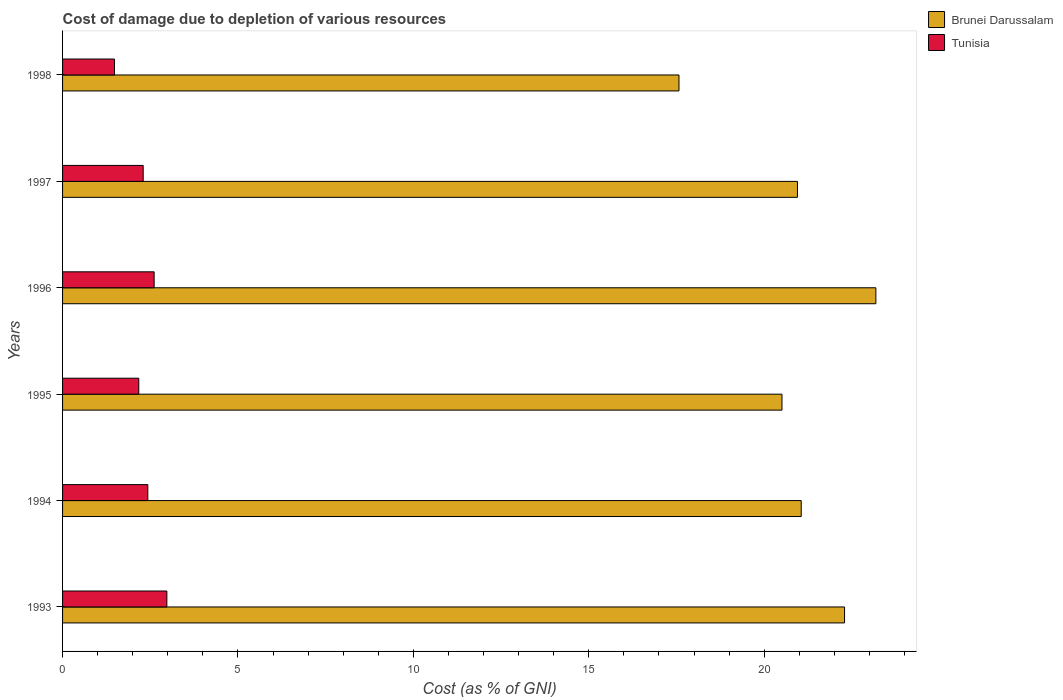Are the number of bars on each tick of the Y-axis equal?
Offer a very short reply. Yes. How many bars are there on the 6th tick from the top?
Provide a short and direct response. 2. How many bars are there on the 5th tick from the bottom?
Your answer should be very brief. 2. What is the label of the 5th group of bars from the top?
Your response must be concise. 1994. What is the cost of damage caused due to the depletion of various resources in Tunisia in 1996?
Make the answer very short. 2.61. Across all years, what is the maximum cost of damage caused due to the depletion of various resources in Tunisia?
Your answer should be compact. 2.97. Across all years, what is the minimum cost of damage caused due to the depletion of various resources in Brunei Darussalam?
Give a very brief answer. 17.57. In which year was the cost of damage caused due to the depletion of various resources in Tunisia maximum?
Your response must be concise. 1993. What is the total cost of damage caused due to the depletion of various resources in Tunisia in the graph?
Give a very brief answer. 13.97. What is the difference between the cost of damage caused due to the depletion of various resources in Tunisia in 1995 and that in 1996?
Provide a succinct answer. -0.44. What is the difference between the cost of damage caused due to the depletion of various resources in Brunei Darussalam in 1997 and the cost of damage caused due to the depletion of various resources in Tunisia in 1998?
Offer a terse response. 19.47. What is the average cost of damage caused due to the depletion of various resources in Brunei Darussalam per year?
Your answer should be very brief. 20.93. In the year 1998, what is the difference between the cost of damage caused due to the depletion of various resources in Brunei Darussalam and cost of damage caused due to the depletion of various resources in Tunisia?
Ensure brevity in your answer.  16.09. In how many years, is the cost of damage caused due to the depletion of various resources in Tunisia greater than 16 %?
Ensure brevity in your answer.  0. What is the ratio of the cost of damage caused due to the depletion of various resources in Brunei Darussalam in 1993 to that in 1995?
Offer a terse response. 1.09. Is the difference between the cost of damage caused due to the depletion of various resources in Brunei Darussalam in 1993 and 1994 greater than the difference between the cost of damage caused due to the depletion of various resources in Tunisia in 1993 and 1994?
Provide a short and direct response. Yes. What is the difference between the highest and the second highest cost of damage caused due to the depletion of various resources in Tunisia?
Give a very brief answer. 0.36. What is the difference between the highest and the lowest cost of damage caused due to the depletion of various resources in Brunei Darussalam?
Offer a very short reply. 5.61. In how many years, is the cost of damage caused due to the depletion of various resources in Tunisia greater than the average cost of damage caused due to the depletion of various resources in Tunisia taken over all years?
Provide a succinct answer. 3. What does the 2nd bar from the top in 1997 represents?
Make the answer very short. Brunei Darussalam. What does the 2nd bar from the bottom in 1995 represents?
Your response must be concise. Tunisia. How many bars are there?
Your answer should be compact. 12. Are all the bars in the graph horizontal?
Keep it short and to the point. Yes. What is the difference between two consecutive major ticks on the X-axis?
Give a very brief answer. 5. Are the values on the major ticks of X-axis written in scientific E-notation?
Make the answer very short. No. Does the graph contain any zero values?
Offer a very short reply. No. Does the graph contain grids?
Offer a very short reply. No. Where does the legend appear in the graph?
Your answer should be very brief. Top right. How many legend labels are there?
Give a very brief answer. 2. How are the legend labels stacked?
Provide a succinct answer. Vertical. What is the title of the graph?
Keep it short and to the point. Cost of damage due to depletion of various resources. What is the label or title of the X-axis?
Ensure brevity in your answer.  Cost (as % of GNI). What is the label or title of the Y-axis?
Your answer should be very brief. Years. What is the Cost (as % of GNI) of Brunei Darussalam in 1993?
Provide a short and direct response. 22.29. What is the Cost (as % of GNI) of Tunisia in 1993?
Provide a short and direct response. 2.97. What is the Cost (as % of GNI) in Brunei Darussalam in 1994?
Provide a succinct answer. 21.06. What is the Cost (as % of GNI) in Tunisia in 1994?
Your answer should be very brief. 2.43. What is the Cost (as % of GNI) of Brunei Darussalam in 1995?
Offer a very short reply. 20.51. What is the Cost (as % of GNI) in Tunisia in 1995?
Ensure brevity in your answer.  2.17. What is the Cost (as % of GNI) in Brunei Darussalam in 1996?
Make the answer very short. 23.18. What is the Cost (as % of GNI) of Tunisia in 1996?
Ensure brevity in your answer.  2.61. What is the Cost (as % of GNI) of Brunei Darussalam in 1997?
Make the answer very short. 20.95. What is the Cost (as % of GNI) in Tunisia in 1997?
Offer a terse response. 2.3. What is the Cost (as % of GNI) in Brunei Darussalam in 1998?
Ensure brevity in your answer.  17.57. What is the Cost (as % of GNI) in Tunisia in 1998?
Provide a short and direct response. 1.48. Across all years, what is the maximum Cost (as % of GNI) of Brunei Darussalam?
Your answer should be compact. 23.18. Across all years, what is the maximum Cost (as % of GNI) in Tunisia?
Give a very brief answer. 2.97. Across all years, what is the minimum Cost (as % of GNI) in Brunei Darussalam?
Your response must be concise. 17.57. Across all years, what is the minimum Cost (as % of GNI) in Tunisia?
Offer a terse response. 1.48. What is the total Cost (as % of GNI) of Brunei Darussalam in the graph?
Provide a short and direct response. 125.56. What is the total Cost (as % of GNI) in Tunisia in the graph?
Ensure brevity in your answer.  13.97. What is the difference between the Cost (as % of GNI) of Brunei Darussalam in 1993 and that in 1994?
Your answer should be very brief. 1.24. What is the difference between the Cost (as % of GNI) of Tunisia in 1993 and that in 1994?
Your answer should be very brief. 0.54. What is the difference between the Cost (as % of GNI) in Brunei Darussalam in 1993 and that in 1995?
Ensure brevity in your answer.  1.78. What is the difference between the Cost (as % of GNI) in Tunisia in 1993 and that in 1995?
Ensure brevity in your answer.  0.8. What is the difference between the Cost (as % of GNI) of Brunei Darussalam in 1993 and that in 1996?
Give a very brief answer. -0.89. What is the difference between the Cost (as % of GNI) of Tunisia in 1993 and that in 1996?
Your response must be concise. 0.36. What is the difference between the Cost (as % of GNI) of Brunei Darussalam in 1993 and that in 1997?
Provide a succinct answer. 1.34. What is the difference between the Cost (as % of GNI) of Tunisia in 1993 and that in 1997?
Your response must be concise. 0.67. What is the difference between the Cost (as % of GNI) in Brunei Darussalam in 1993 and that in 1998?
Make the answer very short. 4.72. What is the difference between the Cost (as % of GNI) of Tunisia in 1993 and that in 1998?
Keep it short and to the point. 1.49. What is the difference between the Cost (as % of GNI) in Brunei Darussalam in 1994 and that in 1995?
Ensure brevity in your answer.  0.55. What is the difference between the Cost (as % of GNI) in Tunisia in 1994 and that in 1995?
Ensure brevity in your answer.  0.26. What is the difference between the Cost (as % of GNI) of Brunei Darussalam in 1994 and that in 1996?
Your response must be concise. -2.13. What is the difference between the Cost (as % of GNI) of Tunisia in 1994 and that in 1996?
Make the answer very short. -0.18. What is the difference between the Cost (as % of GNI) in Brunei Darussalam in 1994 and that in 1997?
Offer a terse response. 0.11. What is the difference between the Cost (as % of GNI) in Tunisia in 1994 and that in 1997?
Offer a very short reply. 0.13. What is the difference between the Cost (as % of GNI) of Brunei Darussalam in 1994 and that in 1998?
Make the answer very short. 3.48. What is the difference between the Cost (as % of GNI) of Tunisia in 1994 and that in 1998?
Ensure brevity in your answer.  0.95. What is the difference between the Cost (as % of GNI) of Brunei Darussalam in 1995 and that in 1996?
Your response must be concise. -2.68. What is the difference between the Cost (as % of GNI) of Tunisia in 1995 and that in 1996?
Provide a succinct answer. -0.44. What is the difference between the Cost (as % of GNI) in Brunei Darussalam in 1995 and that in 1997?
Make the answer very short. -0.44. What is the difference between the Cost (as % of GNI) in Tunisia in 1995 and that in 1997?
Your response must be concise. -0.13. What is the difference between the Cost (as % of GNI) in Brunei Darussalam in 1995 and that in 1998?
Give a very brief answer. 2.94. What is the difference between the Cost (as % of GNI) in Tunisia in 1995 and that in 1998?
Make the answer very short. 0.69. What is the difference between the Cost (as % of GNI) of Brunei Darussalam in 1996 and that in 1997?
Offer a terse response. 2.24. What is the difference between the Cost (as % of GNI) of Tunisia in 1996 and that in 1997?
Offer a very short reply. 0.31. What is the difference between the Cost (as % of GNI) in Brunei Darussalam in 1996 and that in 1998?
Your answer should be compact. 5.61. What is the difference between the Cost (as % of GNI) in Tunisia in 1996 and that in 1998?
Give a very brief answer. 1.13. What is the difference between the Cost (as % of GNI) in Brunei Darussalam in 1997 and that in 1998?
Make the answer very short. 3.38. What is the difference between the Cost (as % of GNI) in Tunisia in 1997 and that in 1998?
Your response must be concise. 0.82. What is the difference between the Cost (as % of GNI) of Brunei Darussalam in 1993 and the Cost (as % of GNI) of Tunisia in 1994?
Ensure brevity in your answer.  19.86. What is the difference between the Cost (as % of GNI) in Brunei Darussalam in 1993 and the Cost (as % of GNI) in Tunisia in 1995?
Your answer should be compact. 20.12. What is the difference between the Cost (as % of GNI) in Brunei Darussalam in 1993 and the Cost (as % of GNI) in Tunisia in 1996?
Ensure brevity in your answer.  19.68. What is the difference between the Cost (as % of GNI) in Brunei Darussalam in 1993 and the Cost (as % of GNI) in Tunisia in 1997?
Offer a terse response. 19.99. What is the difference between the Cost (as % of GNI) in Brunei Darussalam in 1993 and the Cost (as % of GNI) in Tunisia in 1998?
Your answer should be very brief. 20.81. What is the difference between the Cost (as % of GNI) in Brunei Darussalam in 1994 and the Cost (as % of GNI) in Tunisia in 1995?
Offer a terse response. 18.88. What is the difference between the Cost (as % of GNI) in Brunei Darussalam in 1994 and the Cost (as % of GNI) in Tunisia in 1996?
Ensure brevity in your answer.  18.44. What is the difference between the Cost (as % of GNI) of Brunei Darussalam in 1994 and the Cost (as % of GNI) of Tunisia in 1997?
Provide a short and direct response. 18.76. What is the difference between the Cost (as % of GNI) in Brunei Darussalam in 1994 and the Cost (as % of GNI) in Tunisia in 1998?
Give a very brief answer. 19.57. What is the difference between the Cost (as % of GNI) of Brunei Darussalam in 1995 and the Cost (as % of GNI) of Tunisia in 1996?
Provide a short and direct response. 17.9. What is the difference between the Cost (as % of GNI) in Brunei Darussalam in 1995 and the Cost (as % of GNI) in Tunisia in 1997?
Your response must be concise. 18.21. What is the difference between the Cost (as % of GNI) in Brunei Darussalam in 1995 and the Cost (as % of GNI) in Tunisia in 1998?
Keep it short and to the point. 19.03. What is the difference between the Cost (as % of GNI) of Brunei Darussalam in 1996 and the Cost (as % of GNI) of Tunisia in 1997?
Your answer should be compact. 20.89. What is the difference between the Cost (as % of GNI) of Brunei Darussalam in 1996 and the Cost (as % of GNI) of Tunisia in 1998?
Provide a short and direct response. 21.7. What is the difference between the Cost (as % of GNI) of Brunei Darussalam in 1997 and the Cost (as % of GNI) of Tunisia in 1998?
Your answer should be very brief. 19.47. What is the average Cost (as % of GNI) in Brunei Darussalam per year?
Keep it short and to the point. 20.93. What is the average Cost (as % of GNI) of Tunisia per year?
Offer a very short reply. 2.33. In the year 1993, what is the difference between the Cost (as % of GNI) in Brunei Darussalam and Cost (as % of GNI) in Tunisia?
Provide a short and direct response. 19.32. In the year 1994, what is the difference between the Cost (as % of GNI) in Brunei Darussalam and Cost (as % of GNI) in Tunisia?
Your answer should be very brief. 18.63. In the year 1995, what is the difference between the Cost (as % of GNI) of Brunei Darussalam and Cost (as % of GNI) of Tunisia?
Your answer should be very brief. 18.33. In the year 1996, what is the difference between the Cost (as % of GNI) in Brunei Darussalam and Cost (as % of GNI) in Tunisia?
Offer a very short reply. 20.57. In the year 1997, what is the difference between the Cost (as % of GNI) in Brunei Darussalam and Cost (as % of GNI) in Tunisia?
Keep it short and to the point. 18.65. In the year 1998, what is the difference between the Cost (as % of GNI) of Brunei Darussalam and Cost (as % of GNI) of Tunisia?
Give a very brief answer. 16.09. What is the ratio of the Cost (as % of GNI) of Brunei Darussalam in 1993 to that in 1994?
Offer a very short reply. 1.06. What is the ratio of the Cost (as % of GNI) of Tunisia in 1993 to that in 1994?
Provide a short and direct response. 1.22. What is the ratio of the Cost (as % of GNI) of Brunei Darussalam in 1993 to that in 1995?
Provide a succinct answer. 1.09. What is the ratio of the Cost (as % of GNI) in Tunisia in 1993 to that in 1995?
Your response must be concise. 1.37. What is the ratio of the Cost (as % of GNI) of Brunei Darussalam in 1993 to that in 1996?
Make the answer very short. 0.96. What is the ratio of the Cost (as % of GNI) of Tunisia in 1993 to that in 1996?
Your response must be concise. 1.14. What is the ratio of the Cost (as % of GNI) of Brunei Darussalam in 1993 to that in 1997?
Make the answer very short. 1.06. What is the ratio of the Cost (as % of GNI) of Tunisia in 1993 to that in 1997?
Make the answer very short. 1.29. What is the ratio of the Cost (as % of GNI) in Brunei Darussalam in 1993 to that in 1998?
Ensure brevity in your answer.  1.27. What is the ratio of the Cost (as % of GNI) of Tunisia in 1993 to that in 1998?
Your answer should be compact. 2.01. What is the ratio of the Cost (as % of GNI) of Brunei Darussalam in 1994 to that in 1995?
Ensure brevity in your answer.  1.03. What is the ratio of the Cost (as % of GNI) in Tunisia in 1994 to that in 1995?
Offer a very short reply. 1.12. What is the ratio of the Cost (as % of GNI) in Brunei Darussalam in 1994 to that in 1996?
Your answer should be compact. 0.91. What is the ratio of the Cost (as % of GNI) of Tunisia in 1994 to that in 1996?
Provide a short and direct response. 0.93. What is the ratio of the Cost (as % of GNI) in Tunisia in 1994 to that in 1997?
Provide a succinct answer. 1.06. What is the ratio of the Cost (as % of GNI) in Brunei Darussalam in 1994 to that in 1998?
Your answer should be very brief. 1.2. What is the ratio of the Cost (as % of GNI) in Tunisia in 1994 to that in 1998?
Ensure brevity in your answer.  1.64. What is the ratio of the Cost (as % of GNI) of Brunei Darussalam in 1995 to that in 1996?
Make the answer very short. 0.88. What is the ratio of the Cost (as % of GNI) in Tunisia in 1995 to that in 1996?
Provide a succinct answer. 0.83. What is the ratio of the Cost (as % of GNI) of Brunei Darussalam in 1995 to that in 1997?
Offer a terse response. 0.98. What is the ratio of the Cost (as % of GNI) in Tunisia in 1995 to that in 1997?
Your answer should be very brief. 0.95. What is the ratio of the Cost (as % of GNI) of Brunei Darussalam in 1995 to that in 1998?
Offer a very short reply. 1.17. What is the ratio of the Cost (as % of GNI) of Tunisia in 1995 to that in 1998?
Keep it short and to the point. 1.47. What is the ratio of the Cost (as % of GNI) of Brunei Darussalam in 1996 to that in 1997?
Your answer should be very brief. 1.11. What is the ratio of the Cost (as % of GNI) of Tunisia in 1996 to that in 1997?
Give a very brief answer. 1.14. What is the ratio of the Cost (as % of GNI) of Brunei Darussalam in 1996 to that in 1998?
Give a very brief answer. 1.32. What is the ratio of the Cost (as % of GNI) of Tunisia in 1996 to that in 1998?
Offer a terse response. 1.76. What is the ratio of the Cost (as % of GNI) in Brunei Darussalam in 1997 to that in 1998?
Ensure brevity in your answer.  1.19. What is the ratio of the Cost (as % of GNI) of Tunisia in 1997 to that in 1998?
Give a very brief answer. 1.55. What is the difference between the highest and the second highest Cost (as % of GNI) of Brunei Darussalam?
Ensure brevity in your answer.  0.89. What is the difference between the highest and the second highest Cost (as % of GNI) of Tunisia?
Offer a very short reply. 0.36. What is the difference between the highest and the lowest Cost (as % of GNI) in Brunei Darussalam?
Make the answer very short. 5.61. What is the difference between the highest and the lowest Cost (as % of GNI) in Tunisia?
Offer a very short reply. 1.49. 